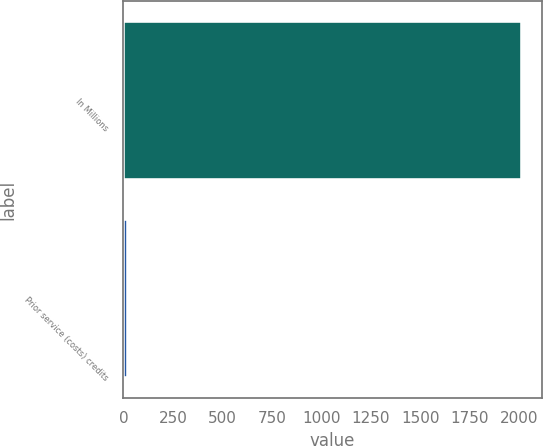Convert chart to OTSL. <chart><loc_0><loc_0><loc_500><loc_500><bar_chart><fcel>In Millions<fcel>Prior service (costs) credits<nl><fcel>2015<fcel>23.8<nl></chart> 